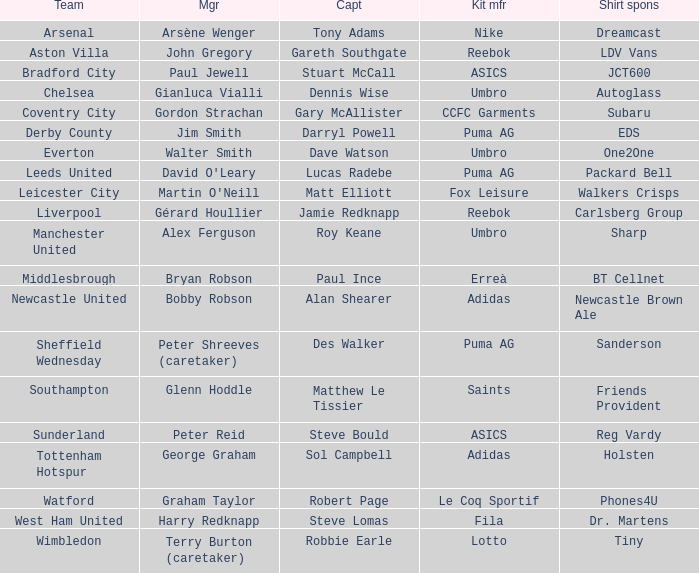Which team does David O'leary manage? Leeds United. 